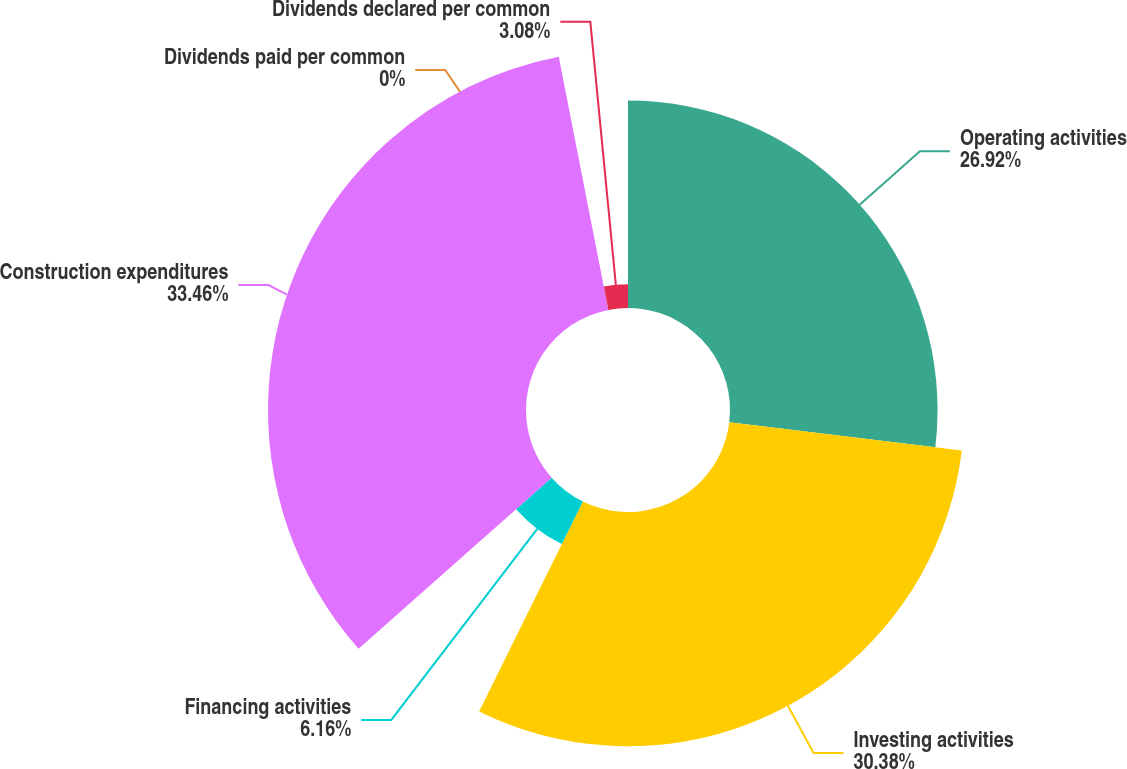Convert chart. <chart><loc_0><loc_0><loc_500><loc_500><pie_chart><fcel>Operating activities<fcel>Investing activities<fcel>Financing activities<fcel>Construction expenditures<fcel>Dividends paid per common<fcel>Dividends declared per common<nl><fcel>26.92%<fcel>30.38%<fcel>6.16%<fcel>33.46%<fcel>0.0%<fcel>3.08%<nl></chart> 